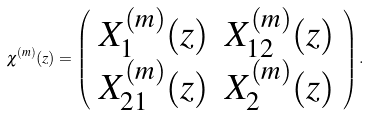Convert formula to latex. <formula><loc_0><loc_0><loc_500><loc_500>\chi ^ { ( m ) } ( z ) = \left ( \begin{array} { c c } X _ { 1 } ^ { ( m ) } ( z ) & X _ { 1 2 } ^ { ( m ) } ( z ) \\ X _ { 2 1 } ^ { ( m ) } ( z ) & X _ { 2 } ^ { ( m ) } ( z ) \end{array} \right ) .</formula> 